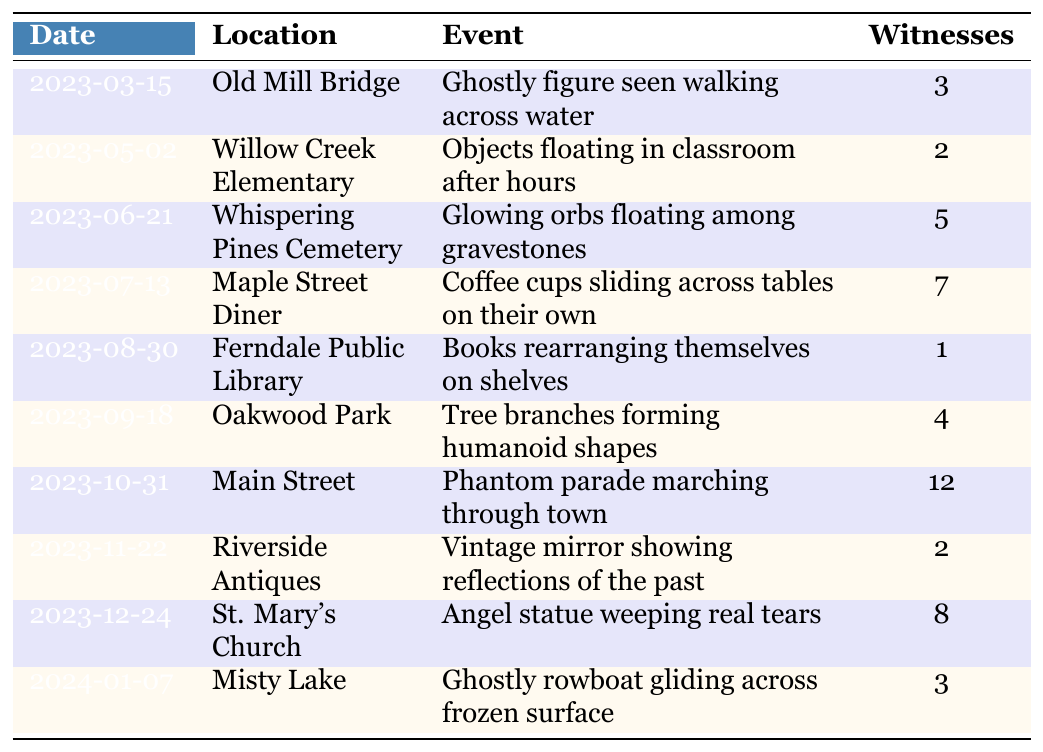What location reported the highest number of witnesses? The table shows the number of witnesses for each event. The highest count is for the event on Main Street with 12 witnesses.
Answer: Main Street How many total witnesses were reported across all events? To find the total, I add the number of witnesses for each event: 3 + 2 + 5 + 7 + 1 + 4 + 12 + 2 + 8 + 3 = 47.
Answer: 47 Was there a supernatural sighting at Ferndale Public Library? Yes, there was an event reported at Ferndale Public Library where books rearranged themselves on shelves.
Answer: Yes Which event had fewer than 5 witnesses? The events with fewer than 5 witnesses are those at Willow Creek Elementary (2), Ferndale Public Library (1), and Riverside Antiques (2).
Answer: Willow Creek Elementary, Ferndale Public Library, Riverside Antiques What is the date of the third sighting in the table? The third sighting is on June 21, 2023, which is located at Whispering Pines Cemetery.
Answer: 2023-06-21 How many more witnesses were at Maple Street Diner than at Ferndale Public Library? Maple Street Diner had 7 witnesses, while Ferndale Public Library had 1 witness. The difference is 7 - 1 = 6.
Answer: 6 Is there an event involving a crying statue? Yes, there is an event at St. Mary's Church where an angel statue was reported to be weeping real tears.
Answer: Yes Which sighting occurred first, the ghostly figure at Old Mill Bridge or the phantom parade on Main Street? The ghostly figure at Old Mill Bridge occurred on March 15, 2023, while the phantom parade was on October 31, 2023. Therefore, the ghostly figure sighting occurred first.
Answer: Ghostly figure at Old Mill Bridge What percentage of the total sightings had more than 5 witnesses? There are 10 sightings, and 3 of those had more than 5 witnesses (Maple Street Diner, Main Street, and St. Mary's Church). To find the percentage, (3/10) * 100 = 30%.
Answer: 30% What was the event with the most unique description? The event considered to have the most unique description is the “Phantom parade marching through town,” due to its festive nature and the number of witnesses.
Answer: Phantom parade marching through town 